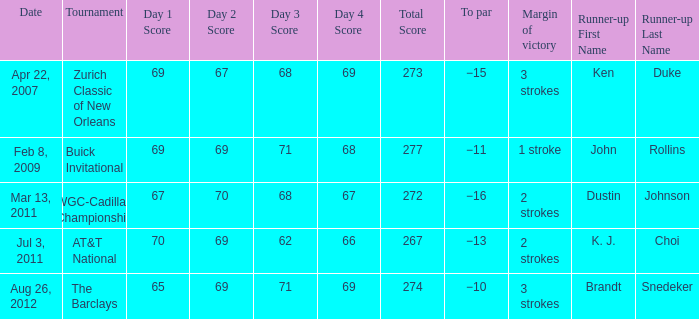Who finished second in the contest with a 2-stroke victory margin and a to par of -16? Dustin Johnson. 